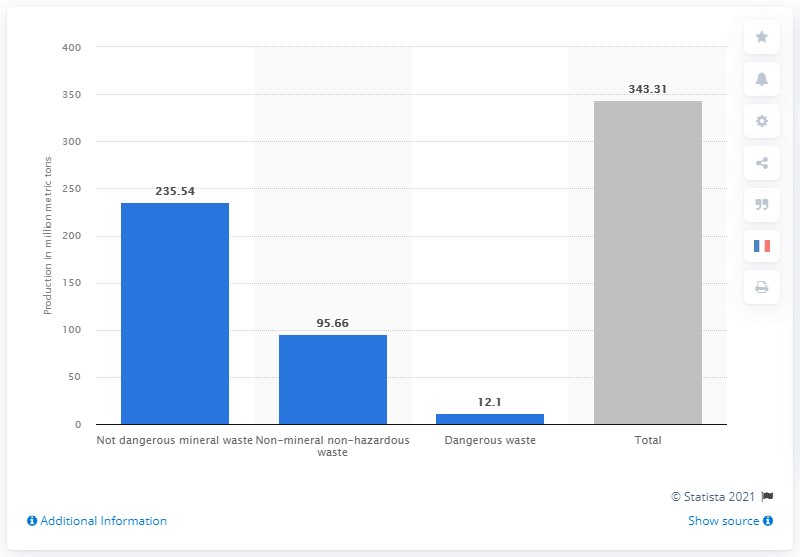Highlight a few significant elements in this photo. In 2018, 95.66 non-mineral non-hazardous waste was produced in France. 